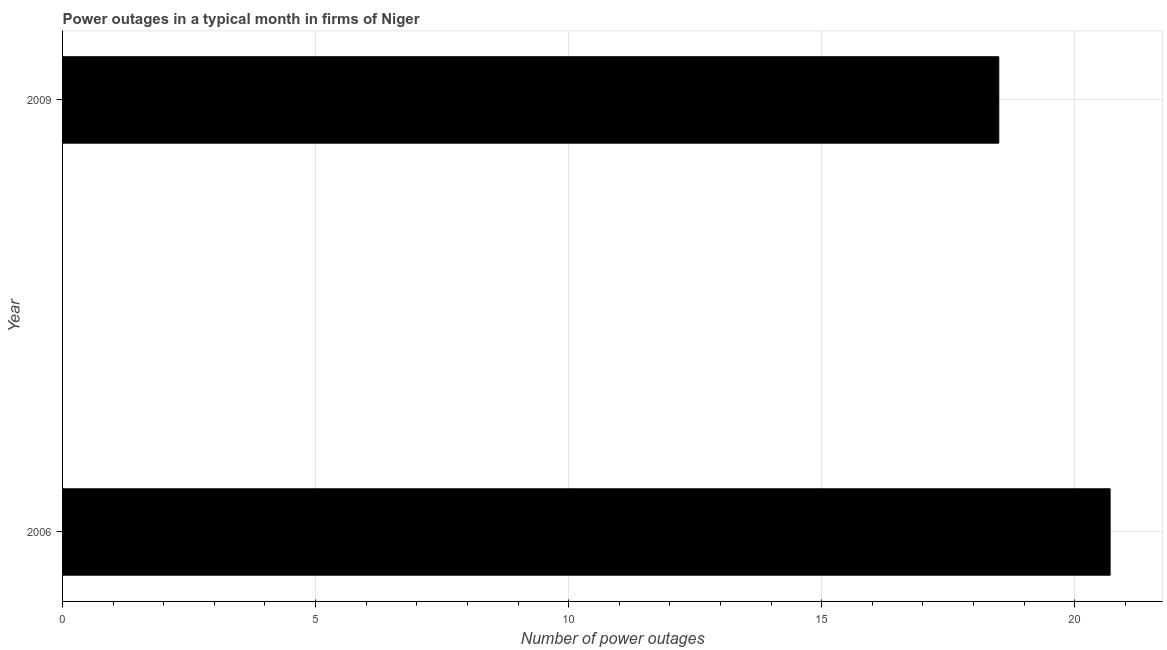Does the graph contain any zero values?
Provide a succinct answer. No. Does the graph contain grids?
Your answer should be very brief. Yes. What is the title of the graph?
Offer a terse response. Power outages in a typical month in firms of Niger. What is the label or title of the X-axis?
Your response must be concise. Number of power outages. What is the number of power outages in 2009?
Give a very brief answer. 18.5. Across all years, what is the maximum number of power outages?
Give a very brief answer. 20.7. Across all years, what is the minimum number of power outages?
Ensure brevity in your answer.  18.5. In which year was the number of power outages minimum?
Give a very brief answer. 2009. What is the sum of the number of power outages?
Provide a short and direct response. 39.2. What is the average number of power outages per year?
Offer a very short reply. 19.6. What is the median number of power outages?
Your response must be concise. 19.6. In how many years, is the number of power outages greater than 7 ?
Ensure brevity in your answer.  2. What is the ratio of the number of power outages in 2006 to that in 2009?
Your answer should be very brief. 1.12. How many years are there in the graph?
Provide a short and direct response. 2. What is the difference between two consecutive major ticks on the X-axis?
Offer a very short reply. 5. Are the values on the major ticks of X-axis written in scientific E-notation?
Provide a short and direct response. No. What is the Number of power outages of 2006?
Give a very brief answer. 20.7. What is the difference between the Number of power outages in 2006 and 2009?
Provide a succinct answer. 2.2. What is the ratio of the Number of power outages in 2006 to that in 2009?
Offer a terse response. 1.12. 